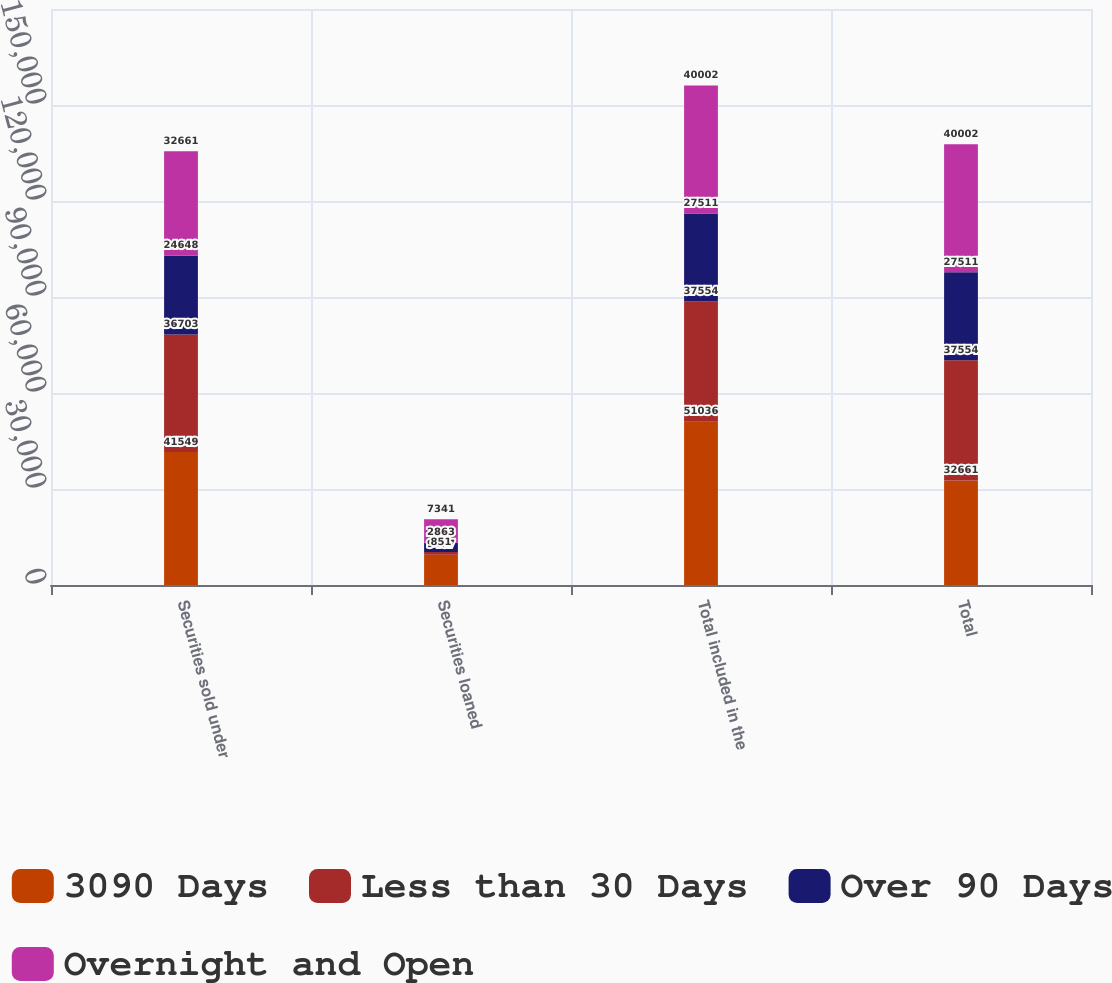Convert chart. <chart><loc_0><loc_0><loc_500><loc_500><stacked_bar_chart><ecel><fcel>Securities sold under<fcel>Securities loaned<fcel>Total included in the<fcel>Total<nl><fcel>3090 Days<fcel>41549<fcel>9487<fcel>51036<fcel>32661<nl><fcel>Less than 30 Days<fcel>36703<fcel>851<fcel>37554<fcel>37554<nl><fcel>Over 90 Days<fcel>24648<fcel>2863<fcel>27511<fcel>27511<nl><fcel>Overnight and Open<fcel>32661<fcel>7341<fcel>40002<fcel>40002<nl></chart> 